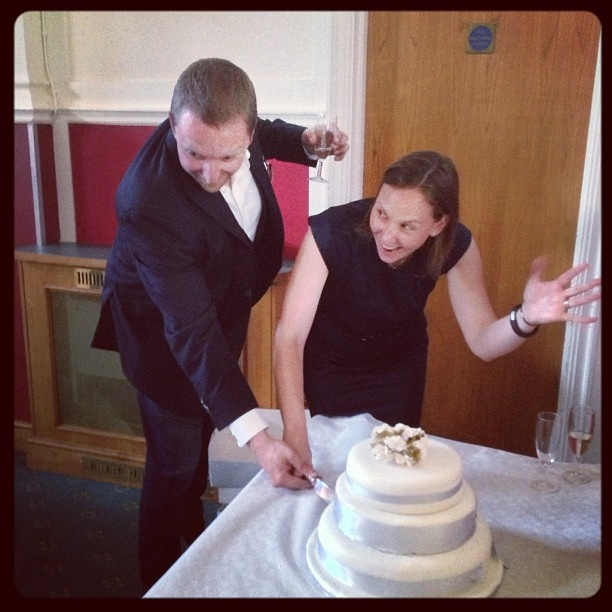Describe the objects in this image and their specific colors. I can see people in black, gray, lightgray, and purple tones, people in black, lightpink, maroon, and brown tones, dining table in black, darkgray, lavender, and gray tones, cake in black, lightgray, darkgray, and tan tones, and tv in black and gray tones in this image. 